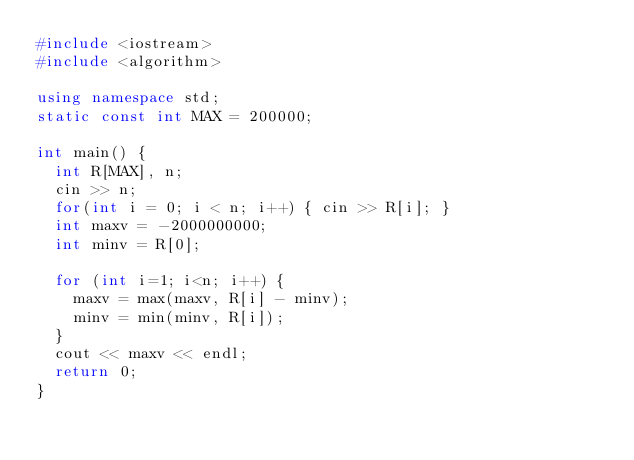<code> <loc_0><loc_0><loc_500><loc_500><_C++_>#include <iostream>
#include <algorithm>

using namespace std;
static const int MAX = 200000;

int main() {
  int R[MAX], n;
  cin >> n;
  for(int i = 0; i < n; i++) { cin >> R[i]; }
  int maxv = -2000000000;
  int minv = R[0];

  for (int i=1; i<n; i++) {
    maxv = max(maxv, R[i] - minv);
    minv = min(minv, R[i]);
  }
  cout << maxv << endl;
  return 0;
}</code> 